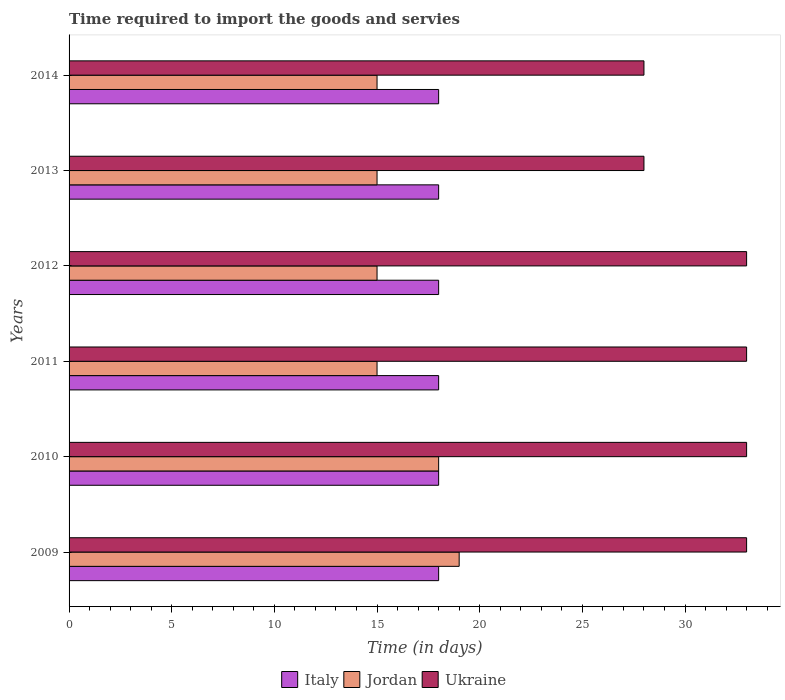How many different coloured bars are there?
Your response must be concise. 3. How many groups of bars are there?
Provide a succinct answer. 6. Are the number of bars per tick equal to the number of legend labels?
Your answer should be very brief. Yes. Are the number of bars on each tick of the Y-axis equal?
Provide a succinct answer. Yes. What is the number of days required to import the goods and services in Italy in 2011?
Provide a succinct answer. 18. Across all years, what is the maximum number of days required to import the goods and services in Ukraine?
Your answer should be compact. 33. Across all years, what is the minimum number of days required to import the goods and services in Ukraine?
Your answer should be compact. 28. In which year was the number of days required to import the goods and services in Ukraine maximum?
Offer a very short reply. 2009. What is the total number of days required to import the goods and services in Italy in the graph?
Your response must be concise. 108. What is the difference between the number of days required to import the goods and services in Ukraine in 2013 and that in 2014?
Offer a very short reply. 0. What is the difference between the number of days required to import the goods and services in Ukraine in 2009 and the number of days required to import the goods and services in Jordan in 2014?
Offer a terse response. 18. What is the average number of days required to import the goods and services in Ukraine per year?
Your answer should be very brief. 31.33. In the year 2014, what is the difference between the number of days required to import the goods and services in Jordan and number of days required to import the goods and services in Italy?
Ensure brevity in your answer.  -3. What is the ratio of the number of days required to import the goods and services in Ukraine in 2011 to that in 2013?
Make the answer very short. 1.18. Is the number of days required to import the goods and services in Ukraine in 2010 less than that in 2013?
Provide a succinct answer. No. Is the difference between the number of days required to import the goods and services in Jordan in 2010 and 2013 greater than the difference between the number of days required to import the goods and services in Italy in 2010 and 2013?
Make the answer very short. Yes. What is the difference between the highest and the lowest number of days required to import the goods and services in Jordan?
Offer a very short reply. 4. In how many years, is the number of days required to import the goods and services in Italy greater than the average number of days required to import the goods and services in Italy taken over all years?
Provide a succinct answer. 0. Is the sum of the number of days required to import the goods and services in Ukraine in 2009 and 2010 greater than the maximum number of days required to import the goods and services in Italy across all years?
Ensure brevity in your answer.  Yes. What does the 3rd bar from the top in 2014 represents?
Offer a very short reply. Italy. What does the 2nd bar from the bottom in 2009 represents?
Provide a succinct answer. Jordan. How many bars are there?
Provide a short and direct response. 18. How many years are there in the graph?
Your answer should be very brief. 6. What is the difference between two consecutive major ticks on the X-axis?
Keep it short and to the point. 5. Are the values on the major ticks of X-axis written in scientific E-notation?
Offer a very short reply. No. Where does the legend appear in the graph?
Offer a very short reply. Bottom center. How are the legend labels stacked?
Your answer should be very brief. Horizontal. What is the title of the graph?
Ensure brevity in your answer.  Time required to import the goods and servies. Does "Bangladesh" appear as one of the legend labels in the graph?
Your answer should be very brief. No. What is the label or title of the X-axis?
Ensure brevity in your answer.  Time (in days). What is the Time (in days) in Italy in 2009?
Offer a terse response. 18. What is the Time (in days) in Ukraine in 2009?
Make the answer very short. 33. What is the Time (in days) of Italy in 2010?
Give a very brief answer. 18. What is the Time (in days) of Ukraine in 2010?
Make the answer very short. 33. What is the Time (in days) in Jordan in 2011?
Ensure brevity in your answer.  15. What is the Time (in days) in Jordan in 2012?
Offer a terse response. 15. What is the Time (in days) of Ukraine in 2012?
Make the answer very short. 33. What is the Time (in days) in Italy in 2013?
Your answer should be very brief. 18. What is the Time (in days) of Italy in 2014?
Your answer should be very brief. 18. What is the Time (in days) in Jordan in 2014?
Your answer should be very brief. 15. What is the Time (in days) in Ukraine in 2014?
Make the answer very short. 28. Across all years, what is the maximum Time (in days) of Jordan?
Provide a succinct answer. 19. Across all years, what is the maximum Time (in days) of Ukraine?
Keep it short and to the point. 33. Across all years, what is the minimum Time (in days) in Italy?
Your answer should be very brief. 18. Across all years, what is the minimum Time (in days) of Jordan?
Keep it short and to the point. 15. What is the total Time (in days) in Italy in the graph?
Ensure brevity in your answer.  108. What is the total Time (in days) of Jordan in the graph?
Make the answer very short. 97. What is the total Time (in days) of Ukraine in the graph?
Offer a very short reply. 188. What is the difference between the Time (in days) of Italy in 2009 and that in 2010?
Keep it short and to the point. 0. What is the difference between the Time (in days) in Jordan in 2009 and that in 2010?
Your answer should be very brief. 1. What is the difference between the Time (in days) in Italy in 2009 and that in 2011?
Keep it short and to the point. 0. What is the difference between the Time (in days) of Jordan in 2009 and that in 2011?
Provide a short and direct response. 4. What is the difference between the Time (in days) in Jordan in 2009 and that in 2013?
Ensure brevity in your answer.  4. What is the difference between the Time (in days) in Ukraine in 2009 and that in 2014?
Your answer should be compact. 5. What is the difference between the Time (in days) of Italy in 2010 and that in 2012?
Your answer should be very brief. 0. What is the difference between the Time (in days) in Jordan in 2010 and that in 2012?
Ensure brevity in your answer.  3. What is the difference between the Time (in days) in Ukraine in 2010 and that in 2012?
Ensure brevity in your answer.  0. What is the difference between the Time (in days) of Italy in 2010 and that in 2013?
Offer a terse response. 0. What is the difference between the Time (in days) of Jordan in 2010 and that in 2013?
Your answer should be compact. 3. What is the difference between the Time (in days) of Ukraine in 2010 and that in 2013?
Offer a terse response. 5. What is the difference between the Time (in days) in Ukraine in 2010 and that in 2014?
Make the answer very short. 5. What is the difference between the Time (in days) of Italy in 2011 and that in 2012?
Your answer should be compact. 0. What is the difference between the Time (in days) in Ukraine in 2011 and that in 2012?
Your answer should be compact. 0. What is the difference between the Time (in days) of Italy in 2011 and that in 2013?
Make the answer very short. 0. What is the difference between the Time (in days) in Jordan in 2011 and that in 2014?
Ensure brevity in your answer.  0. What is the difference between the Time (in days) in Ukraine in 2011 and that in 2014?
Ensure brevity in your answer.  5. What is the difference between the Time (in days) in Jordan in 2012 and that in 2013?
Give a very brief answer. 0. What is the difference between the Time (in days) in Italy in 2012 and that in 2014?
Keep it short and to the point. 0. What is the difference between the Time (in days) in Jordan in 2012 and that in 2014?
Make the answer very short. 0. What is the difference between the Time (in days) in Jordan in 2013 and that in 2014?
Make the answer very short. 0. What is the difference between the Time (in days) in Italy in 2009 and the Time (in days) in Jordan in 2010?
Give a very brief answer. 0. What is the difference between the Time (in days) of Italy in 2009 and the Time (in days) of Jordan in 2012?
Keep it short and to the point. 3. What is the difference between the Time (in days) in Italy in 2009 and the Time (in days) in Ukraine in 2012?
Offer a terse response. -15. What is the difference between the Time (in days) of Jordan in 2009 and the Time (in days) of Ukraine in 2012?
Make the answer very short. -14. What is the difference between the Time (in days) of Jordan in 2009 and the Time (in days) of Ukraine in 2013?
Make the answer very short. -9. What is the difference between the Time (in days) of Italy in 2009 and the Time (in days) of Jordan in 2014?
Give a very brief answer. 3. What is the difference between the Time (in days) of Italy in 2009 and the Time (in days) of Ukraine in 2014?
Ensure brevity in your answer.  -10. What is the difference between the Time (in days) in Jordan in 2009 and the Time (in days) in Ukraine in 2014?
Ensure brevity in your answer.  -9. What is the difference between the Time (in days) in Italy in 2010 and the Time (in days) in Jordan in 2011?
Ensure brevity in your answer.  3. What is the difference between the Time (in days) of Jordan in 2010 and the Time (in days) of Ukraine in 2011?
Provide a short and direct response. -15. What is the difference between the Time (in days) in Italy in 2010 and the Time (in days) in Jordan in 2012?
Offer a terse response. 3. What is the difference between the Time (in days) of Jordan in 2010 and the Time (in days) of Ukraine in 2013?
Offer a terse response. -10. What is the difference between the Time (in days) of Italy in 2010 and the Time (in days) of Jordan in 2014?
Make the answer very short. 3. What is the difference between the Time (in days) of Italy in 2010 and the Time (in days) of Ukraine in 2014?
Your answer should be compact. -10. What is the difference between the Time (in days) of Jordan in 2011 and the Time (in days) of Ukraine in 2012?
Make the answer very short. -18. What is the difference between the Time (in days) of Italy in 2011 and the Time (in days) of Ukraine in 2013?
Provide a short and direct response. -10. What is the difference between the Time (in days) in Italy in 2011 and the Time (in days) in Jordan in 2014?
Provide a succinct answer. 3. What is the difference between the Time (in days) of Jordan in 2011 and the Time (in days) of Ukraine in 2014?
Provide a succinct answer. -13. What is the difference between the Time (in days) of Italy in 2012 and the Time (in days) of Jordan in 2013?
Your answer should be compact. 3. What is the difference between the Time (in days) in Italy in 2012 and the Time (in days) in Ukraine in 2013?
Offer a very short reply. -10. What is the difference between the Time (in days) of Italy in 2012 and the Time (in days) of Jordan in 2014?
Keep it short and to the point. 3. What is the difference between the Time (in days) of Italy in 2012 and the Time (in days) of Ukraine in 2014?
Your answer should be very brief. -10. What is the difference between the Time (in days) of Italy in 2013 and the Time (in days) of Jordan in 2014?
Give a very brief answer. 3. What is the difference between the Time (in days) in Italy in 2013 and the Time (in days) in Ukraine in 2014?
Offer a terse response. -10. What is the difference between the Time (in days) of Jordan in 2013 and the Time (in days) of Ukraine in 2014?
Keep it short and to the point. -13. What is the average Time (in days) of Jordan per year?
Your response must be concise. 16.17. What is the average Time (in days) in Ukraine per year?
Your answer should be compact. 31.33. In the year 2010, what is the difference between the Time (in days) in Jordan and Time (in days) in Ukraine?
Make the answer very short. -15. In the year 2011, what is the difference between the Time (in days) of Italy and Time (in days) of Jordan?
Make the answer very short. 3. In the year 2014, what is the difference between the Time (in days) in Italy and Time (in days) in Ukraine?
Give a very brief answer. -10. What is the ratio of the Time (in days) of Italy in 2009 to that in 2010?
Make the answer very short. 1. What is the ratio of the Time (in days) in Jordan in 2009 to that in 2010?
Provide a succinct answer. 1.06. What is the ratio of the Time (in days) of Jordan in 2009 to that in 2011?
Your answer should be very brief. 1.27. What is the ratio of the Time (in days) of Jordan in 2009 to that in 2012?
Offer a very short reply. 1.27. What is the ratio of the Time (in days) of Ukraine in 2009 to that in 2012?
Keep it short and to the point. 1. What is the ratio of the Time (in days) in Jordan in 2009 to that in 2013?
Offer a very short reply. 1.27. What is the ratio of the Time (in days) in Ukraine in 2009 to that in 2013?
Your response must be concise. 1.18. What is the ratio of the Time (in days) of Italy in 2009 to that in 2014?
Your response must be concise. 1. What is the ratio of the Time (in days) in Jordan in 2009 to that in 2014?
Your response must be concise. 1.27. What is the ratio of the Time (in days) in Ukraine in 2009 to that in 2014?
Give a very brief answer. 1.18. What is the ratio of the Time (in days) in Italy in 2010 to that in 2011?
Your response must be concise. 1. What is the ratio of the Time (in days) of Italy in 2010 to that in 2012?
Provide a succinct answer. 1. What is the ratio of the Time (in days) of Italy in 2010 to that in 2013?
Your answer should be compact. 1. What is the ratio of the Time (in days) of Ukraine in 2010 to that in 2013?
Offer a terse response. 1.18. What is the ratio of the Time (in days) in Italy in 2010 to that in 2014?
Provide a short and direct response. 1. What is the ratio of the Time (in days) in Jordan in 2010 to that in 2014?
Offer a very short reply. 1.2. What is the ratio of the Time (in days) in Ukraine in 2010 to that in 2014?
Offer a very short reply. 1.18. What is the ratio of the Time (in days) in Italy in 2011 to that in 2012?
Ensure brevity in your answer.  1. What is the ratio of the Time (in days) in Ukraine in 2011 to that in 2012?
Provide a succinct answer. 1. What is the ratio of the Time (in days) of Italy in 2011 to that in 2013?
Give a very brief answer. 1. What is the ratio of the Time (in days) in Ukraine in 2011 to that in 2013?
Make the answer very short. 1.18. What is the ratio of the Time (in days) in Jordan in 2011 to that in 2014?
Keep it short and to the point. 1. What is the ratio of the Time (in days) of Ukraine in 2011 to that in 2014?
Keep it short and to the point. 1.18. What is the ratio of the Time (in days) in Italy in 2012 to that in 2013?
Ensure brevity in your answer.  1. What is the ratio of the Time (in days) of Jordan in 2012 to that in 2013?
Give a very brief answer. 1. What is the ratio of the Time (in days) in Ukraine in 2012 to that in 2013?
Your answer should be very brief. 1.18. What is the ratio of the Time (in days) in Jordan in 2012 to that in 2014?
Your answer should be very brief. 1. What is the ratio of the Time (in days) in Ukraine in 2012 to that in 2014?
Give a very brief answer. 1.18. What is the ratio of the Time (in days) of Italy in 2013 to that in 2014?
Make the answer very short. 1. What is the ratio of the Time (in days) of Jordan in 2013 to that in 2014?
Your answer should be compact. 1. What is the difference between the highest and the lowest Time (in days) in Italy?
Provide a succinct answer. 0. What is the difference between the highest and the lowest Time (in days) of Jordan?
Offer a very short reply. 4. 